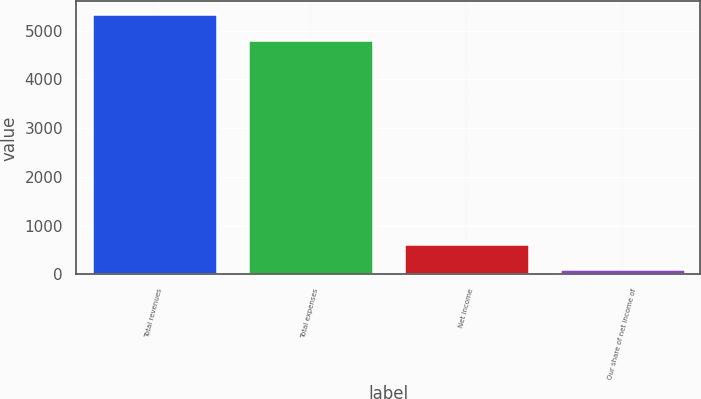<chart> <loc_0><loc_0><loc_500><loc_500><bar_chart><fcel>Total revenues<fcel>Total expenses<fcel>Net income<fcel>Our share of net income of<nl><fcel>5334.93<fcel>4812.3<fcel>622.53<fcel>99.9<nl></chart> 